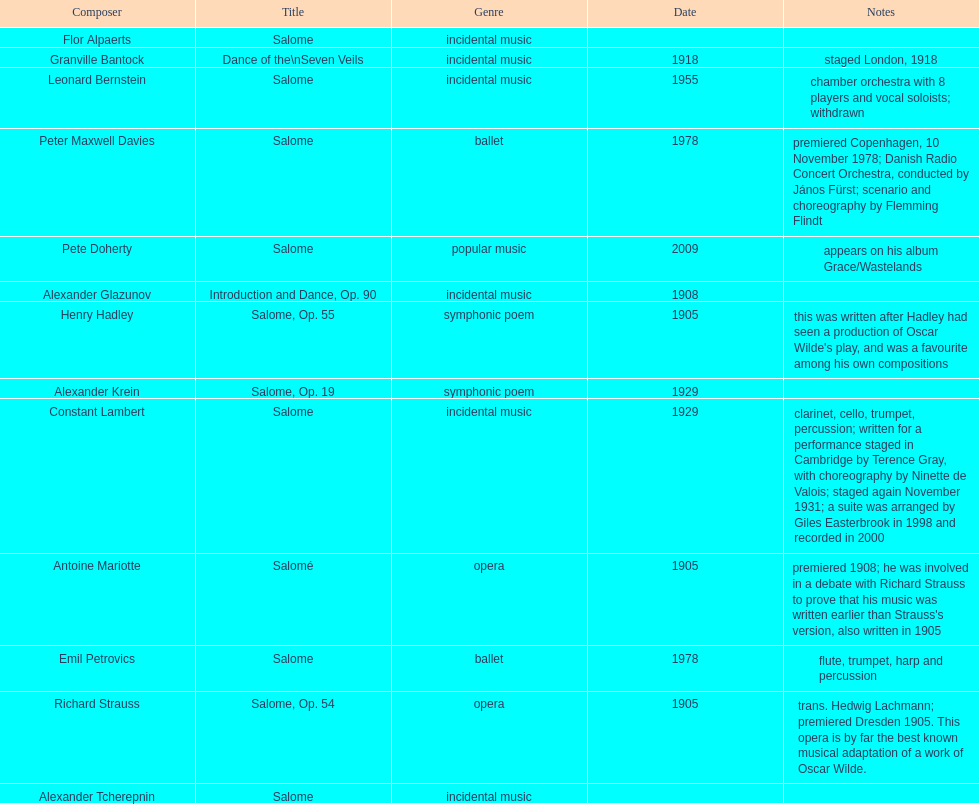Who is next on the list after alexander krein? Constant Lambert. 